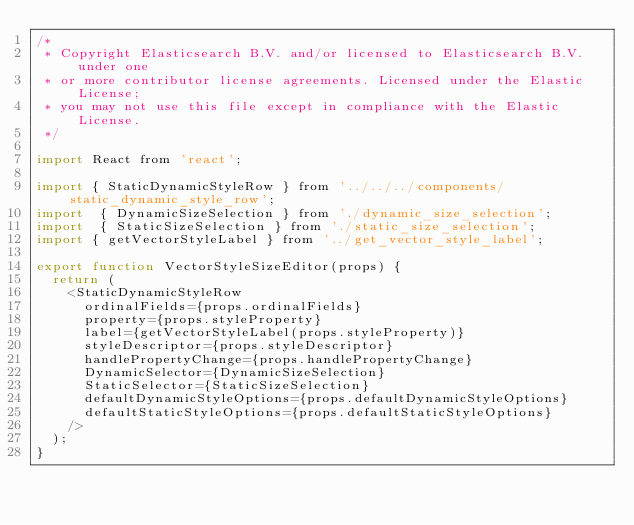Convert code to text. <code><loc_0><loc_0><loc_500><loc_500><_JavaScript_>/*
 * Copyright Elasticsearch B.V. and/or licensed to Elasticsearch B.V. under one
 * or more contributor license agreements. Licensed under the Elastic License;
 * you may not use this file except in compliance with the Elastic License.
 */

import React from 'react';

import { StaticDynamicStyleRow } from '../../../components/static_dynamic_style_row';
import  { DynamicSizeSelection } from './dynamic_size_selection';
import  { StaticSizeSelection } from './static_size_selection';
import { getVectorStyleLabel } from '../get_vector_style_label';

export function VectorStyleSizeEditor(props) {
  return (
    <StaticDynamicStyleRow
      ordinalFields={props.ordinalFields}
      property={props.styleProperty}
      label={getVectorStyleLabel(props.styleProperty)}
      styleDescriptor={props.styleDescriptor}
      handlePropertyChange={props.handlePropertyChange}
      DynamicSelector={DynamicSizeSelection}
      StaticSelector={StaticSizeSelection}
      defaultDynamicStyleOptions={props.defaultDynamicStyleOptions}
      defaultStaticStyleOptions={props.defaultStaticStyleOptions}
    />
  );
}
</code> 